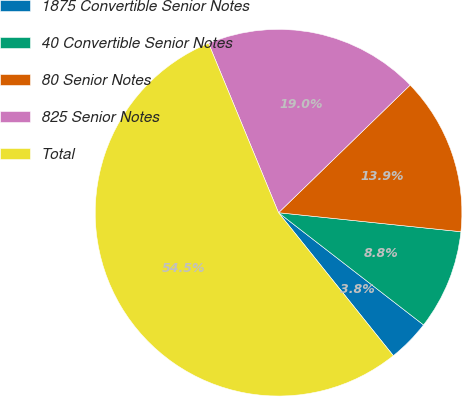Convert chart. <chart><loc_0><loc_0><loc_500><loc_500><pie_chart><fcel>1875 Convertible Senior Notes<fcel>40 Convertible Senior Notes<fcel>80 Senior Notes<fcel>825 Senior Notes<fcel>Total<nl><fcel>3.75%<fcel>8.83%<fcel>13.91%<fcel>18.98%<fcel>54.53%<nl></chart> 